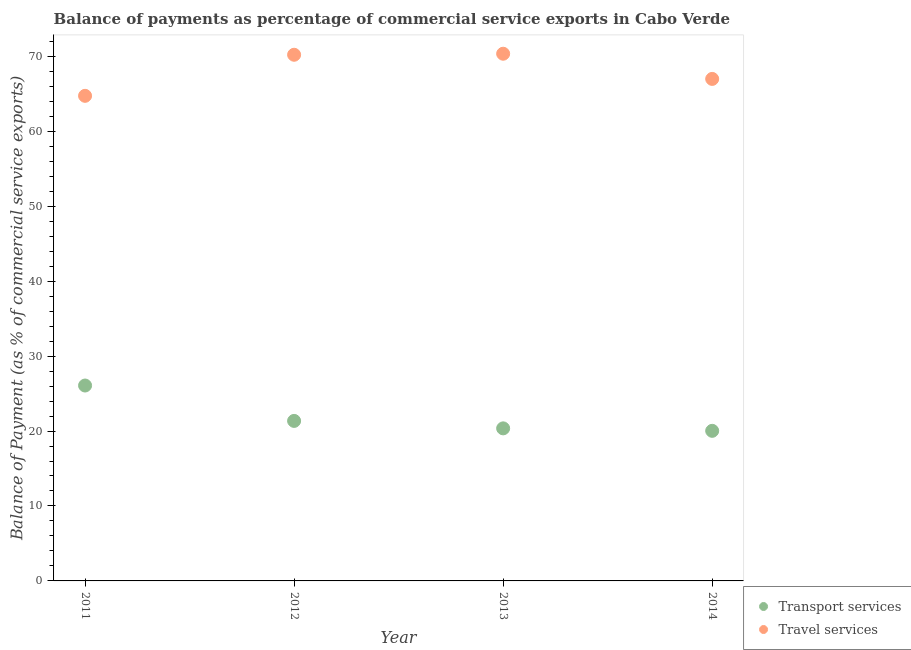What is the balance of payments of transport services in 2013?
Offer a very short reply. 20.36. Across all years, what is the maximum balance of payments of travel services?
Provide a short and direct response. 70.34. Across all years, what is the minimum balance of payments of transport services?
Your answer should be very brief. 20.03. In which year was the balance of payments of transport services minimum?
Offer a very short reply. 2014. What is the total balance of payments of travel services in the graph?
Your answer should be very brief. 272.25. What is the difference between the balance of payments of transport services in 2012 and that in 2013?
Keep it short and to the point. 0.99. What is the difference between the balance of payments of transport services in 2011 and the balance of payments of travel services in 2014?
Keep it short and to the point. -40.91. What is the average balance of payments of travel services per year?
Provide a short and direct response. 68.06. In the year 2012, what is the difference between the balance of payments of travel services and balance of payments of transport services?
Your answer should be compact. 48.85. What is the ratio of the balance of payments of transport services in 2013 to that in 2014?
Offer a very short reply. 1.02. What is the difference between the highest and the second highest balance of payments of travel services?
Provide a succinct answer. 0.14. What is the difference between the highest and the lowest balance of payments of travel services?
Provide a short and direct response. 5.62. Is the sum of the balance of payments of transport services in 2013 and 2014 greater than the maximum balance of payments of travel services across all years?
Make the answer very short. No. Is the balance of payments of transport services strictly greater than the balance of payments of travel services over the years?
Keep it short and to the point. No. Does the graph contain any zero values?
Provide a short and direct response. No. What is the title of the graph?
Your answer should be compact. Balance of payments as percentage of commercial service exports in Cabo Verde. What is the label or title of the X-axis?
Offer a terse response. Year. What is the label or title of the Y-axis?
Your answer should be compact. Balance of Payment (as % of commercial service exports). What is the Balance of Payment (as % of commercial service exports) in Transport services in 2011?
Give a very brief answer. 26.07. What is the Balance of Payment (as % of commercial service exports) of Travel services in 2011?
Make the answer very short. 64.72. What is the Balance of Payment (as % of commercial service exports) of Transport services in 2012?
Offer a very short reply. 21.35. What is the Balance of Payment (as % of commercial service exports) of Travel services in 2012?
Provide a succinct answer. 70.2. What is the Balance of Payment (as % of commercial service exports) of Transport services in 2013?
Give a very brief answer. 20.36. What is the Balance of Payment (as % of commercial service exports) in Travel services in 2013?
Your answer should be compact. 70.34. What is the Balance of Payment (as % of commercial service exports) of Transport services in 2014?
Offer a terse response. 20.03. What is the Balance of Payment (as % of commercial service exports) of Travel services in 2014?
Keep it short and to the point. 66.98. Across all years, what is the maximum Balance of Payment (as % of commercial service exports) in Transport services?
Ensure brevity in your answer.  26.07. Across all years, what is the maximum Balance of Payment (as % of commercial service exports) of Travel services?
Give a very brief answer. 70.34. Across all years, what is the minimum Balance of Payment (as % of commercial service exports) of Transport services?
Keep it short and to the point. 20.03. Across all years, what is the minimum Balance of Payment (as % of commercial service exports) in Travel services?
Your response must be concise. 64.72. What is the total Balance of Payment (as % of commercial service exports) of Transport services in the graph?
Your response must be concise. 87.8. What is the total Balance of Payment (as % of commercial service exports) in Travel services in the graph?
Your response must be concise. 272.25. What is the difference between the Balance of Payment (as % of commercial service exports) in Transport services in 2011 and that in 2012?
Keep it short and to the point. 4.72. What is the difference between the Balance of Payment (as % of commercial service exports) in Travel services in 2011 and that in 2012?
Your answer should be compact. -5.48. What is the difference between the Balance of Payment (as % of commercial service exports) in Transport services in 2011 and that in 2013?
Provide a short and direct response. 5.72. What is the difference between the Balance of Payment (as % of commercial service exports) in Travel services in 2011 and that in 2013?
Provide a succinct answer. -5.62. What is the difference between the Balance of Payment (as % of commercial service exports) in Transport services in 2011 and that in 2014?
Ensure brevity in your answer.  6.05. What is the difference between the Balance of Payment (as % of commercial service exports) of Travel services in 2011 and that in 2014?
Your answer should be compact. -2.26. What is the difference between the Balance of Payment (as % of commercial service exports) in Transport services in 2012 and that in 2013?
Make the answer very short. 0.99. What is the difference between the Balance of Payment (as % of commercial service exports) in Travel services in 2012 and that in 2013?
Provide a short and direct response. -0.14. What is the difference between the Balance of Payment (as % of commercial service exports) of Transport services in 2012 and that in 2014?
Your answer should be compact. 1.32. What is the difference between the Balance of Payment (as % of commercial service exports) of Travel services in 2012 and that in 2014?
Make the answer very short. 3.22. What is the difference between the Balance of Payment (as % of commercial service exports) in Transport services in 2013 and that in 2014?
Offer a terse response. 0.33. What is the difference between the Balance of Payment (as % of commercial service exports) of Travel services in 2013 and that in 2014?
Ensure brevity in your answer.  3.36. What is the difference between the Balance of Payment (as % of commercial service exports) of Transport services in 2011 and the Balance of Payment (as % of commercial service exports) of Travel services in 2012?
Give a very brief answer. -44.13. What is the difference between the Balance of Payment (as % of commercial service exports) in Transport services in 2011 and the Balance of Payment (as % of commercial service exports) in Travel services in 2013?
Ensure brevity in your answer.  -44.27. What is the difference between the Balance of Payment (as % of commercial service exports) in Transport services in 2011 and the Balance of Payment (as % of commercial service exports) in Travel services in 2014?
Offer a terse response. -40.91. What is the difference between the Balance of Payment (as % of commercial service exports) in Transport services in 2012 and the Balance of Payment (as % of commercial service exports) in Travel services in 2013?
Make the answer very short. -48.99. What is the difference between the Balance of Payment (as % of commercial service exports) in Transport services in 2012 and the Balance of Payment (as % of commercial service exports) in Travel services in 2014?
Ensure brevity in your answer.  -45.63. What is the difference between the Balance of Payment (as % of commercial service exports) in Transport services in 2013 and the Balance of Payment (as % of commercial service exports) in Travel services in 2014?
Your answer should be compact. -46.63. What is the average Balance of Payment (as % of commercial service exports) in Transport services per year?
Make the answer very short. 21.95. What is the average Balance of Payment (as % of commercial service exports) in Travel services per year?
Your answer should be compact. 68.06. In the year 2011, what is the difference between the Balance of Payment (as % of commercial service exports) in Transport services and Balance of Payment (as % of commercial service exports) in Travel services?
Your answer should be very brief. -38.65. In the year 2012, what is the difference between the Balance of Payment (as % of commercial service exports) in Transport services and Balance of Payment (as % of commercial service exports) in Travel services?
Your answer should be compact. -48.85. In the year 2013, what is the difference between the Balance of Payment (as % of commercial service exports) of Transport services and Balance of Payment (as % of commercial service exports) of Travel services?
Ensure brevity in your answer.  -49.99. In the year 2014, what is the difference between the Balance of Payment (as % of commercial service exports) in Transport services and Balance of Payment (as % of commercial service exports) in Travel services?
Your response must be concise. -46.96. What is the ratio of the Balance of Payment (as % of commercial service exports) of Transport services in 2011 to that in 2012?
Keep it short and to the point. 1.22. What is the ratio of the Balance of Payment (as % of commercial service exports) of Travel services in 2011 to that in 2012?
Make the answer very short. 0.92. What is the ratio of the Balance of Payment (as % of commercial service exports) in Transport services in 2011 to that in 2013?
Your response must be concise. 1.28. What is the ratio of the Balance of Payment (as % of commercial service exports) of Travel services in 2011 to that in 2013?
Make the answer very short. 0.92. What is the ratio of the Balance of Payment (as % of commercial service exports) in Transport services in 2011 to that in 2014?
Your response must be concise. 1.3. What is the ratio of the Balance of Payment (as % of commercial service exports) in Travel services in 2011 to that in 2014?
Provide a short and direct response. 0.97. What is the ratio of the Balance of Payment (as % of commercial service exports) in Transport services in 2012 to that in 2013?
Your answer should be compact. 1.05. What is the ratio of the Balance of Payment (as % of commercial service exports) of Transport services in 2012 to that in 2014?
Your answer should be compact. 1.07. What is the ratio of the Balance of Payment (as % of commercial service exports) of Travel services in 2012 to that in 2014?
Your response must be concise. 1.05. What is the ratio of the Balance of Payment (as % of commercial service exports) of Transport services in 2013 to that in 2014?
Offer a very short reply. 1.02. What is the ratio of the Balance of Payment (as % of commercial service exports) of Travel services in 2013 to that in 2014?
Give a very brief answer. 1.05. What is the difference between the highest and the second highest Balance of Payment (as % of commercial service exports) of Transport services?
Keep it short and to the point. 4.72. What is the difference between the highest and the second highest Balance of Payment (as % of commercial service exports) of Travel services?
Make the answer very short. 0.14. What is the difference between the highest and the lowest Balance of Payment (as % of commercial service exports) of Transport services?
Give a very brief answer. 6.05. What is the difference between the highest and the lowest Balance of Payment (as % of commercial service exports) of Travel services?
Give a very brief answer. 5.62. 